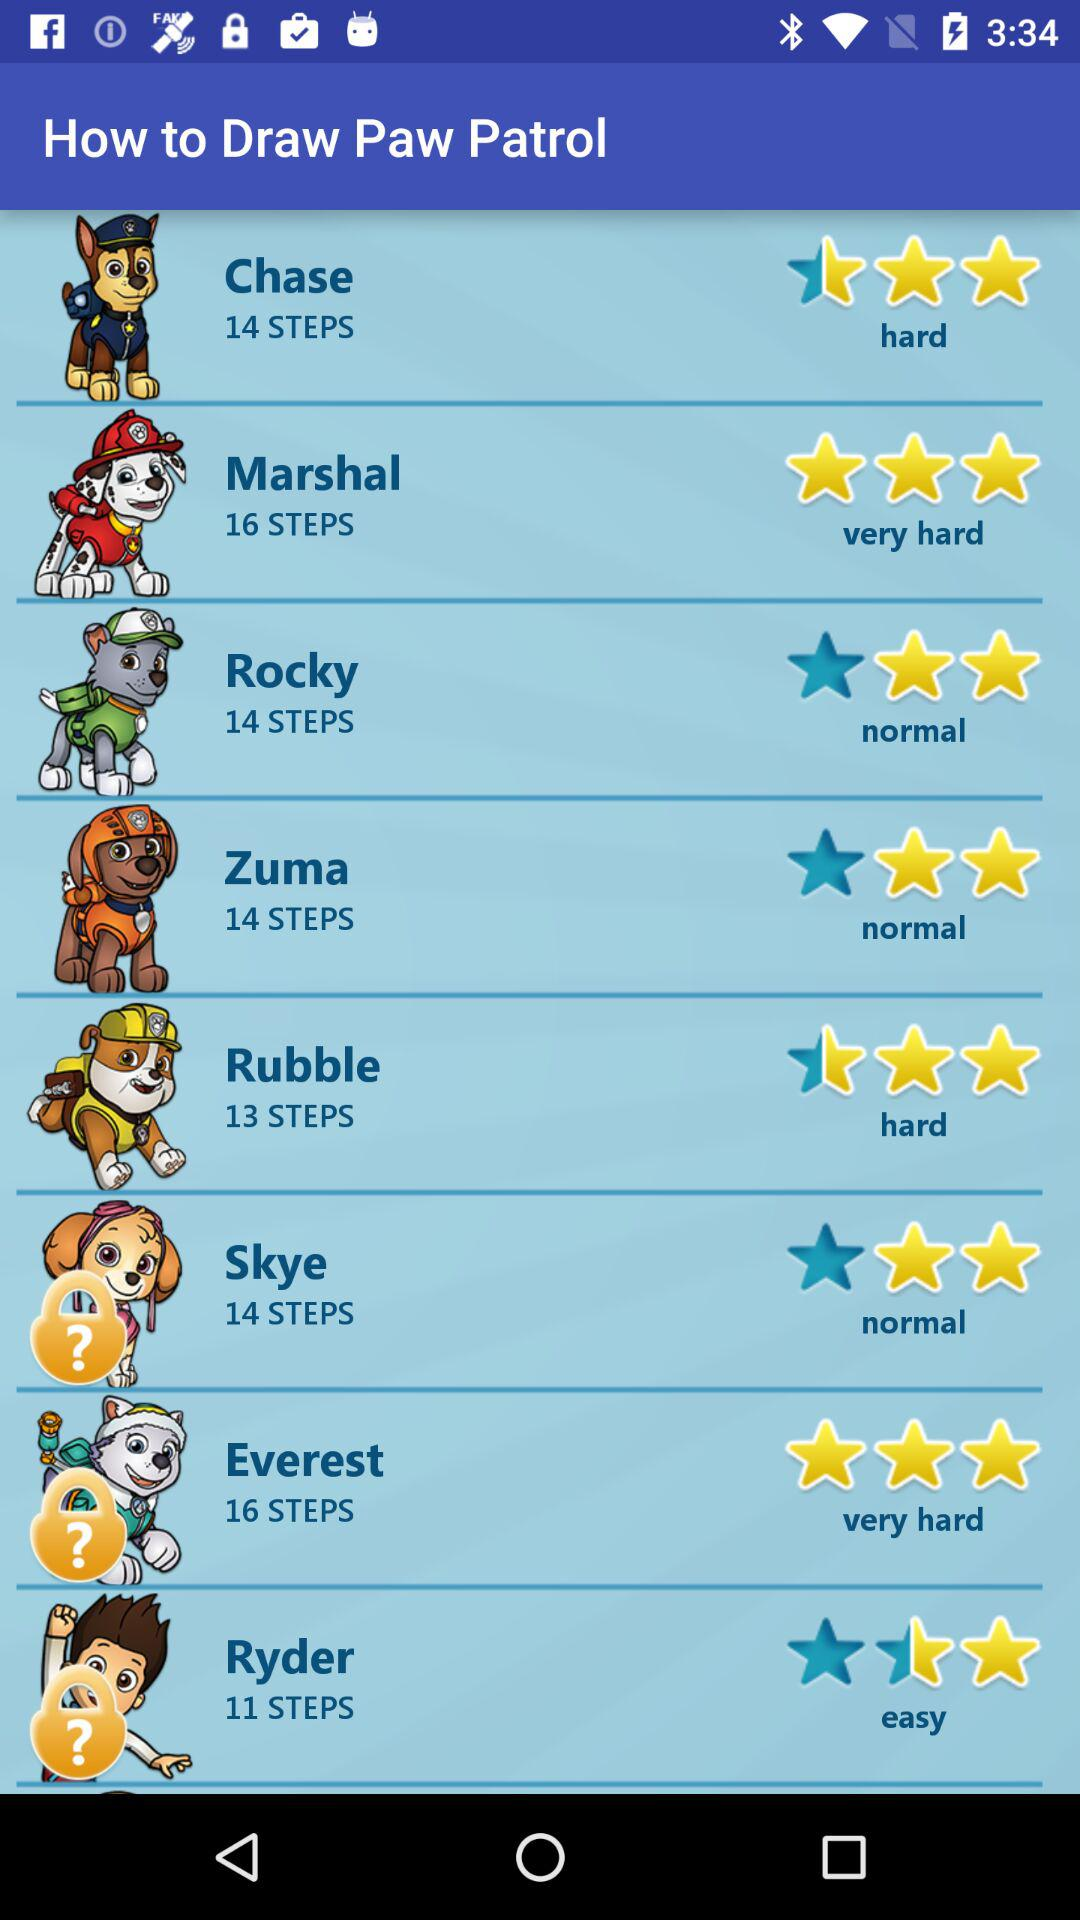What is the star rating of Everest? The rating is 3 stars. 